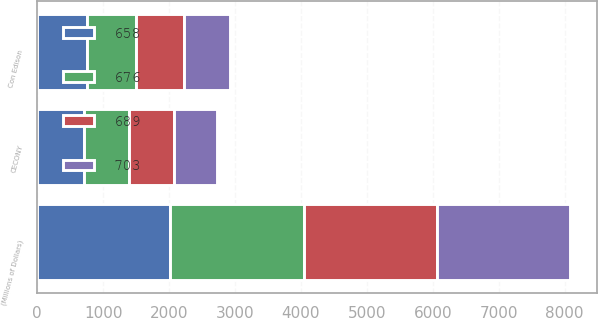Convert chart. <chart><loc_0><loc_0><loc_500><loc_500><stacked_bar_chart><ecel><fcel>(Millions of Dollars)<fcel>Con Edison<fcel>CECONY<nl><fcel>703<fcel>2019<fcel>707<fcel>658<nl><fcel>689<fcel>2020<fcel>726<fcel>676<nl><fcel>676<fcel>2021<fcel>740<fcel>689<nl><fcel>658<fcel>2022<fcel>755<fcel>703<nl></chart> 